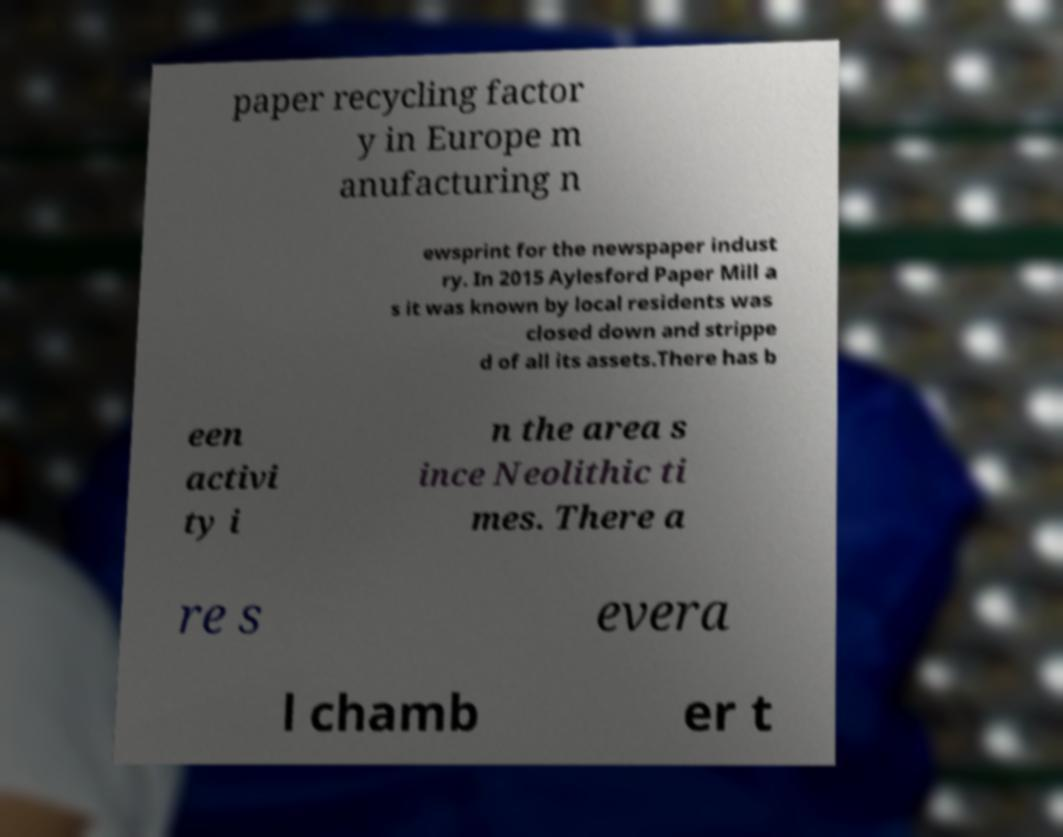Please read and relay the text visible in this image. What does it say? paper recycling factor y in Europe m anufacturing n ewsprint for the newspaper indust ry. In 2015 Aylesford Paper Mill a s it was known by local residents was closed down and strippe d of all its assets.There has b een activi ty i n the area s ince Neolithic ti mes. There a re s evera l chamb er t 